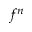<formula> <loc_0><loc_0><loc_500><loc_500>f ^ { n }</formula> 